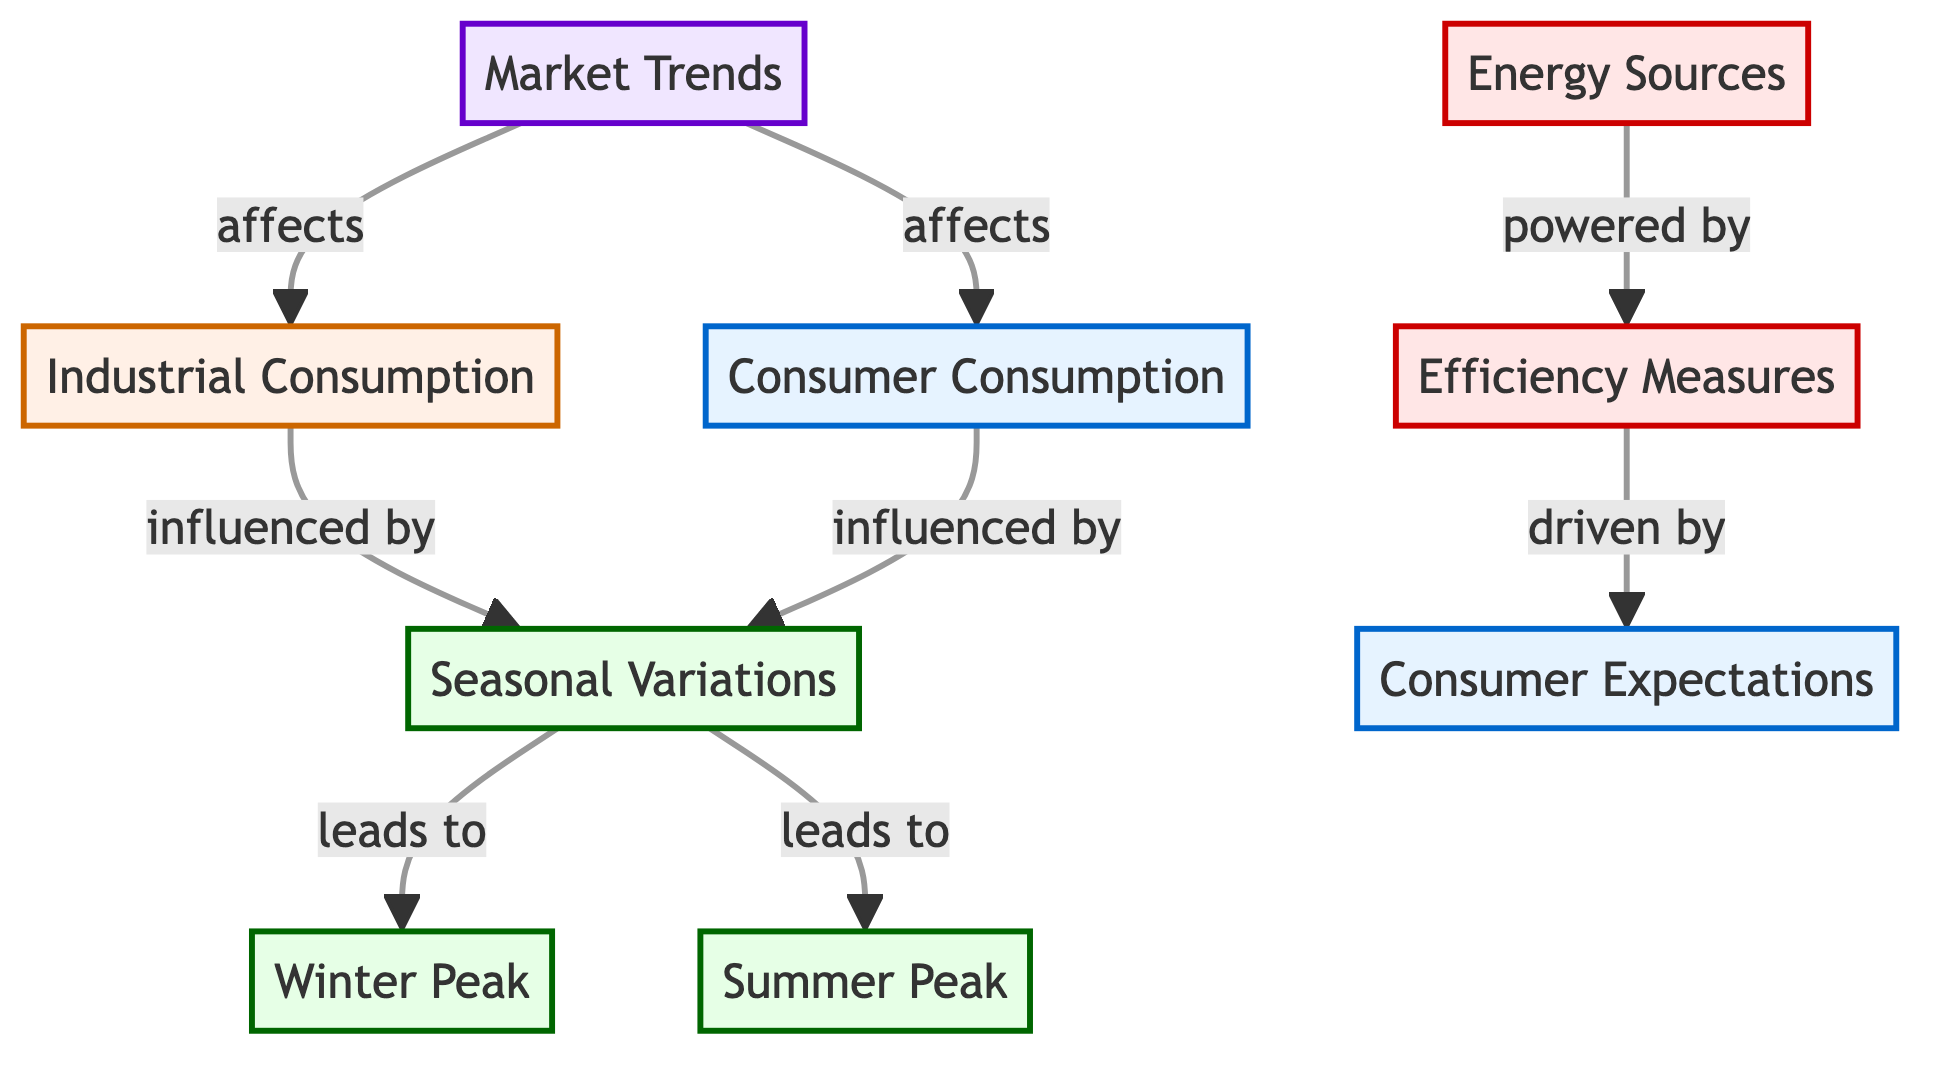what are the two main seasonal peaks in energy consumption? The diagram clearly indicates that the two main seasonal peaks in energy consumption are labeled as "Winter Peak" and "Summer Peak." These nodes are directly connected to the "Seasonal Variations" node, which signifies they are the primary outcomes of seasonal variations in energy consumption.
Answer: Winter Peak, Summer Peak how many nodes are there in the diagram? To determine the total number of nodes, I count each unique box in the diagram. The nodes present are: Industrial Consumption, Consumer Consumption, Seasonal Variations, Winter Peak, Summer Peak, Energy Sources, Efficiency Measures, Market Trends, and Consumer Expectations. This totals to 9 nodes.
Answer: 9 which factors influence both industrial and consumer consumption? The diagram shows that "Seasonal Variations" influences both "Industrial Consumption" and "Consumer Consumption." Therefore, it is the common factor impacting both areas of energy consumption.
Answer: Seasonal Variations what is the connection between consumer expectations and efficiency measures? The diagram indicates that "Efficiency Measures" are driven by "Consumer Expectations." This means that how consumers expect energy efficiency to be implemented directly influences the strategies for improving efficiency measures in energy consumption.
Answer: Driven by which node is affected by market trends? "Industrial Consumption" and "Consumer Consumption" are both labeled as being affected by "Market Trends." This indicates that the market trends play a significant role in shaping the behavior of both industrial and consumer energy usage.
Answer: Industrial Consumption, Consumer Consumption what drives efficiency measures according to the diagram? The diagram clearly shows that "Efficiency Measures" are driven by "Consumer Expectations." This illustrates that understanding what consumers expect is crucial for developing effective efficiency measures in energy consumption.
Answer: Consumer Expectations how many edges are present in the diagram? To find the total number of edges, I count the connecting arrows between nodes. The edges present in the diagram are: Seasonal Variations to Winter Peak, Seasonal Variations to Summer Peak, Industrial Consumption influenced by Seasonal Variations, Consumer Consumption influenced by Seasonal Variations, Market Trends affects Industrial Consumption, Market Trends affects Consumer Consumption, Energy Sources powered by Efficiency Measures, and Efficiency Measures driven by Consumer Expectations. There are 8 edges in total.
Answer: 8 what type of consumption does the "seasonal variations" node impact? The diagram specifies that "Seasonal Variations" impacts two types of consumption: "Industrial Consumption" and "Consumer Consumption." This means that seasonal changes are significant in influencing both the industrial and consumer sectors regarding energy use.
Answer: Industrial, Consumer 